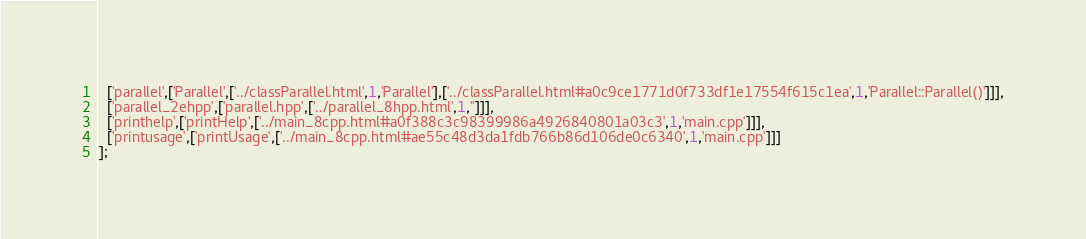<code> <loc_0><loc_0><loc_500><loc_500><_JavaScript_>  ['parallel',['Parallel',['../classParallel.html',1,'Parallel'],['../classParallel.html#a0c9ce1771d0f733df1e17554f615c1ea',1,'Parallel::Parallel()']]],
  ['parallel_2ehpp',['parallel.hpp',['../parallel_8hpp.html',1,'']]],
  ['printhelp',['printHelp',['../main_8cpp.html#a0f388c3c98399986a4926840801a03c3',1,'main.cpp']]],
  ['printusage',['printUsage',['../main_8cpp.html#ae55c48d3da1fdb766b86d106de0c6340',1,'main.cpp']]]
];
</code> 